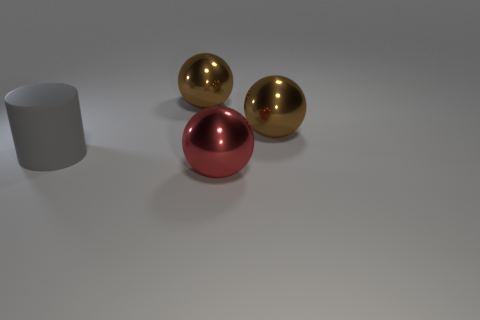What number of small things are gray rubber cylinders or balls?
Your response must be concise. 0. How many big metallic things are both in front of the cylinder and behind the gray cylinder?
Make the answer very short. 0. Is the number of red objects greater than the number of large brown balls?
Your answer should be very brief. No. How many other objects are there of the same shape as the large matte thing?
Ensure brevity in your answer.  0. What is the thing that is on the right side of the cylinder and to the left of the red thing made of?
Your answer should be compact. Metal. What size is the rubber thing?
Offer a very short reply. Large. There is a brown thing that is left of the object that is in front of the big gray matte thing; what number of gray cylinders are behind it?
Provide a short and direct response. 0. There is a metallic object that is right of the big shiny ball in front of the large matte thing; what is its shape?
Provide a short and direct response. Sphere. There is a big object that is in front of the big rubber thing; what color is it?
Ensure brevity in your answer.  Red. What material is the brown sphere that is left of the big ball in front of the big metallic ball that is right of the red thing made of?
Your answer should be very brief. Metal. 